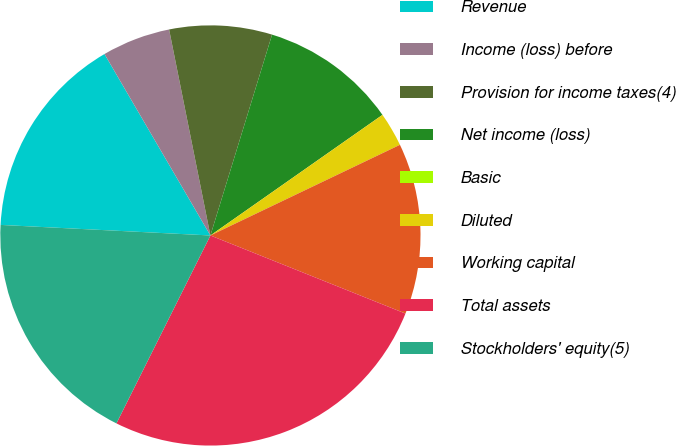<chart> <loc_0><loc_0><loc_500><loc_500><pie_chart><fcel>Revenue<fcel>Income (loss) before<fcel>Provision for income taxes(4)<fcel>Net income (loss)<fcel>Basic<fcel>Diluted<fcel>Working capital<fcel>Total assets<fcel>Stockholders' equity(5)<nl><fcel>15.79%<fcel>5.26%<fcel>7.89%<fcel>10.53%<fcel>0.0%<fcel>2.63%<fcel>13.16%<fcel>26.32%<fcel>18.42%<nl></chart> 